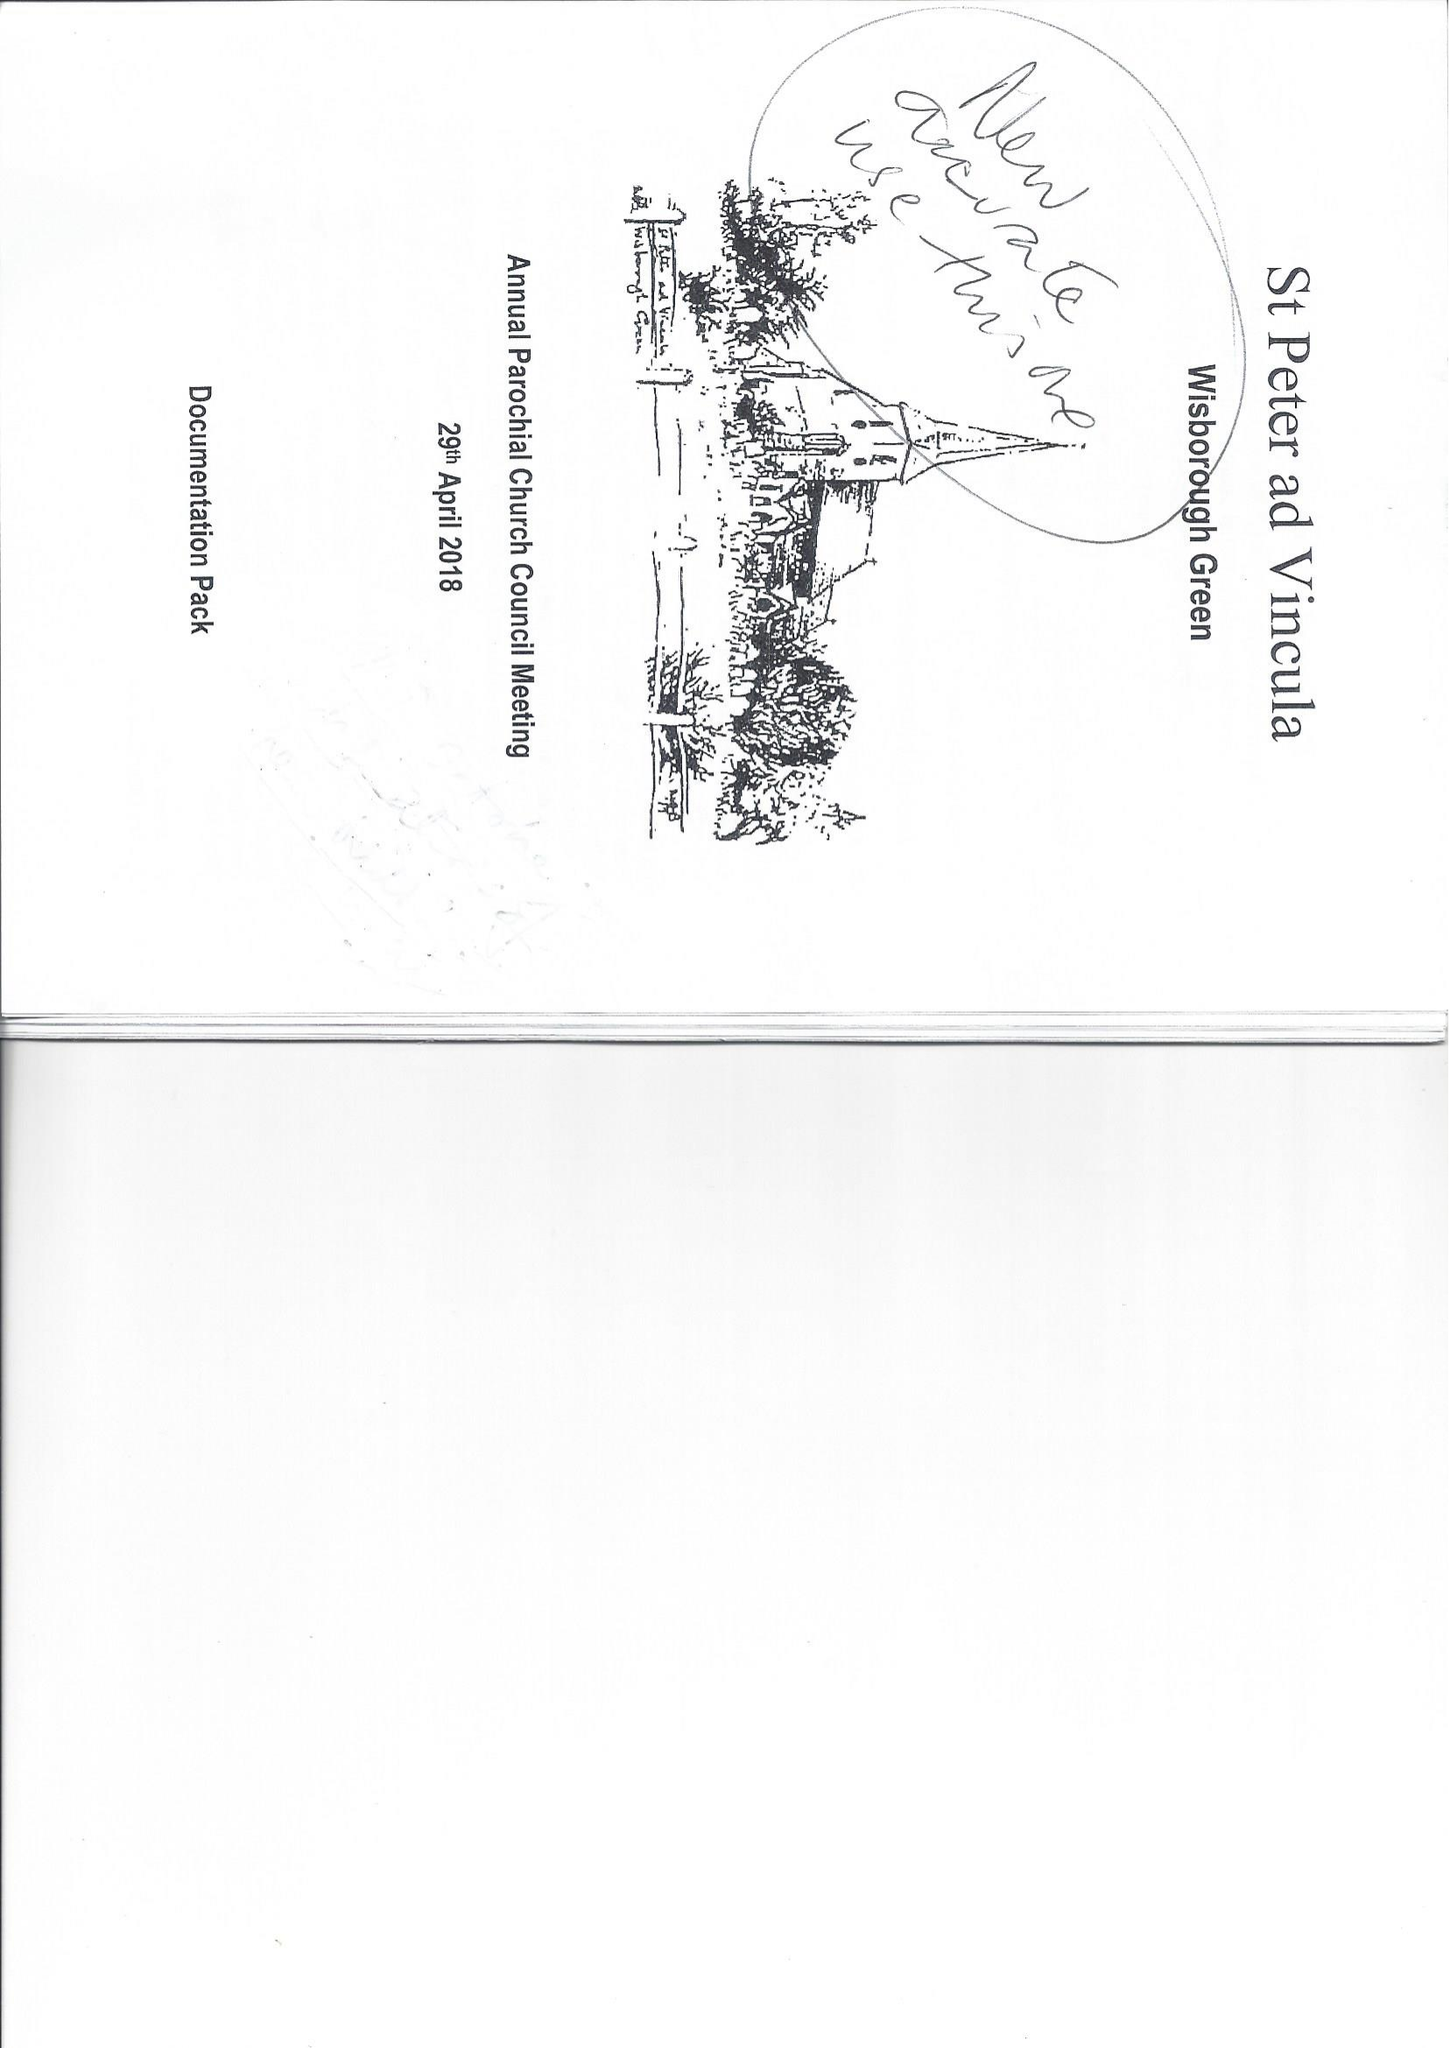What is the value for the charity_name?
Answer the question using a single word or phrase. The Parochial Church Council Of The Ecclesiastical Parish Of St Peter Ad Vincula, Wisborough Green 